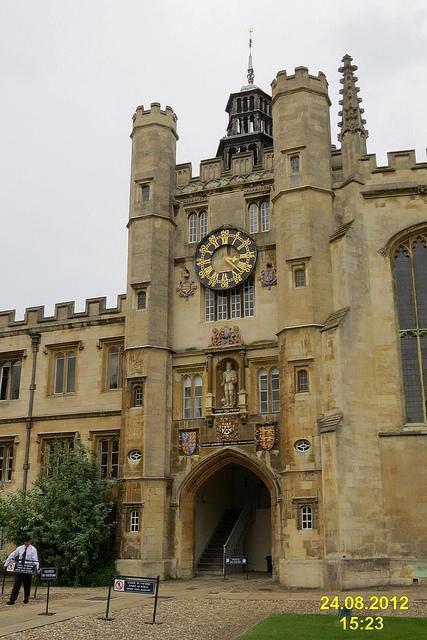What is the person on the left wearing?

Choices:
A) tie
B) scarf
C) cowboy hat
D) suspenders tie 